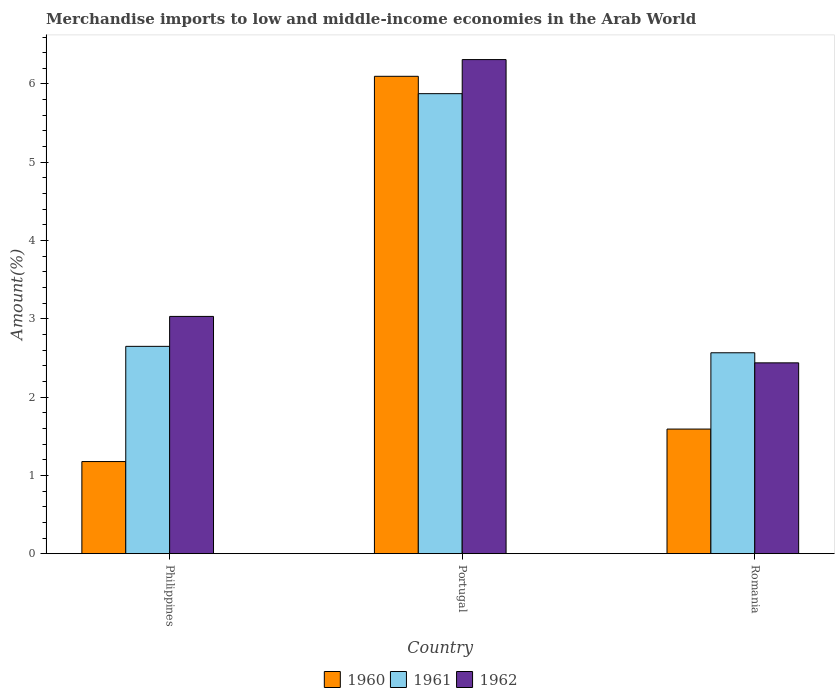How many groups of bars are there?
Your response must be concise. 3. Are the number of bars per tick equal to the number of legend labels?
Your answer should be compact. Yes. How many bars are there on the 2nd tick from the left?
Your response must be concise. 3. How many bars are there on the 3rd tick from the right?
Ensure brevity in your answer.  3. What is the label of the 3rd group of bars from the left?
Provide a short and direct response. Romania. In how many cases, is the number of bars for a given country not equal to the number of legend labels?
Ensure brevity in your answer.  0. What is the percentage of amount earned from merchandise imports in 1962 in Portugal?
Your answer should be compact. 6.31. Across all countries, what is the maximum percentage of amount earned from merchandise imports in 1962?
Make the answer very short. 6.31. Across all countries, what is the minimum percentage of amount earned from merchandise imports in 1961?
Your answer should be compact. 2.57. In which country was the percentage of amount earned from merchandise imports in 1961 minimum?
Give a very brief answer. Romania. What is the total percentage of amount earned from merchandise imports in 1961 in the graph?
Your response must be concise. 11.09. What is the difference between the percentage of amount earned from merchandise imports in 1961 in Portugal and that in Romania?
Your answer should be compact. 3.31. What is the difference between the percentage of amount earned from merchandise imports in 1961 in Portugal and the percentage of amount earned from merchandise imports in 1962 in Philippines?
Keep it short and to the point. 2.85. What is the average percentage of amount earned from merchandise imports in 1962 per country?
Make the answer very short. 3.93. What is the difference between the percentage of amount earned from merchandise imports of/in 1960 and percentage of amount earned from merchandise imports of/in 1962 in Romania?
Offer a very short reply. -0.85. What is the ratio of the percentage of amount earned from merchandise imports in 1960 in Philippines to that in Romania?
Keep it short and to the point. 0.74. Is the percentage of amount earned from merchandise imports in 1962 in Philippines less than that in Portugal?
Provide a short and direct response. Yes. Is the difference between the percentage of amount earned from merchandise imports in 1960 in Philippines and Romania greater than the difference between the percentage of amount earned from merchandise imports in 1962 in Philippines and Romania?
Your answer should be very brief. No. What is the difference between the highest and the second highest percentage of amount earned from merchandise imports in 1960?
Keep it short and to the point. -4.51. What is the difference between the highest and the lowest percentage of amount earned from merchandise imports in 1962?
Provide a succinct answer. 3.87. Are all the bars in the graph horizontal?
Keep it short and to the point. No. What is the difference between two consecutive major ticks on the Y-axis?
Offer a terse response. 1. Where does the legend appear in the graph?
Make the answer very short. Bottom center. How many legend labels are there?
Your response must be concise. 3. How are the legend labels stacked?
Provide a succinct answer. Horizontal. What is the title of the graph?
Provide a short and direct response. Merchandise imports to low and middle-income economies in the Arab World. What is the label or title of the Y-axis?
Ensure brevity in your answer.  Amount(%). What is the Amount(%) in 1960 in Philippines?
Your answer should be very brief. 1.18. What is the Amount(%) in 1961 in Philippines?
Give a very brief answer. 2.65. What is the Amount(%) of 1962 in Philippines?
Ensure brevity in your answer.  3.03. What is the Amount(%) in 1960 in Portugal?
Offer a very short reply. 6.1. What is the Amount(%) in 1961 in Portugal?
Offer a very short reply. 5.88. What is the Amount(%) in 1962 in Portugal?
Make the answer very short. 6.31. What is the Amount(%) of 1960 in Romania?
Offer a terse response. 1.59. What is the Amount(%) of 1961 in Romania?
Make the answer very short. 2.57. What is the Amount(%) in 1962 in Romania?
Your answer should be very brief. 2.44. Across all countries, what is the maximum Amount(%) of 1960?
Make the answer very short. 6.1. Across all countries, what is the maximum Amount(%) of 1961?
Your answer should be compact. 5.88. Across all countries, what is the maximum Amount(%) in 1962?
Your answer should be very brief. 6.31. Across all countries, what is the minimum Amount(%) in 1960?
Offer a very short reply. 1.18. Across all countries, what is the minimum Amount(%) in 1961?
Keep it short and to the point. 2.57. Across all countries, what is the minimum Amount(%) in 1962?
Provide a short and direct response. 2.44. What is the total Amount(%) in 1960 in the graph?
Make the answer very short. 8.87. What is the total Amount(%) of 1961 in the graph?
Your answer should be very brief. 11.09. What is the total Amount(%) in 1962 in the graph?
Provide a short and direct response. 11.78. What is the difference between the Amount(%) of 1960 in Philippines and that in Portugal?
Make the answer very short. -4.92. What is the difference between the Amount(%) of 1961 in Philippines and that in Portugal?
Provide a succinct answer. -3.23. What is the difference between the Amount(%) in 1962 in Philippines and that in Portugal?
Provide a succinct answer. -3.28. What is the difference between the Amount(%) in 1960 in Philippines and that in Romania?
Provide a succinct answer. -0.41. What is the difference between the Amount(%) in 1961 in Philippines and that in Romania?
Make the answer very short. 0.08. What is the difference between the Amount(%) of 1962 in Philippines and that in Romania?
Ensure brevity in your answer.  0.59. What is the difference between the Amount(%) of 1960 in Portugal and that in Romania?
Provide a short and direct response. 4.51. What is the difference between the Amount(%) of 1961 in Portugal and that in Romania?
Ensure brevity in your answer.  3.31. What is the difference between the Amount(%) in 1962 in Portugal and that in Romania?
Ensure brevity in your answer.  3.87. What is the difference between the Amount(%) of 1960 in Philippines and the Amount(%) of 1961 in Portugal?
Offer a terse response. -4.7. What is the difference between the Amount(%) of 1960 in Philippines and the Amount(%) of 1962 in Portugal?
Your answer should be very brief. -5.13. What is the difference between the Amount(%) of 1961 in Philippines and the Amount(%) of 1962 in Portugal?
Keep it short and to the point. -3.66. What is the difference between the Amount(%) in 1960 in Philippines and the Amount(%) in 1961 in Romania?
Keep it short and to the point. -1.39. What is the difference between the Amount(%) in 1960 in Philippines and the Amount(%) in 1962 in Romania?
Give a very brief answer. -1.26. What is the difference between the Amount(%) of 1961 in Philippines and the Amount(%) of 1962 in Romania?
Provide a succinct answer. 0.21. What is the difference between the Amount(%) of 1960 in Portugal and the Amount(%) of 1961 in Romania?
Your answer should be very brief. 3.53. What is the difference between the Amount(%) in 1960 in Portugal and the Amount(%) in 1962 in Romania?
Your answer should be compact. 3.66. What is the difference between the Amount(%) in 1961 in Portugal and the Amount(%) in 1962 in Romania?
Your answer should be compact. 3.44. What is the average Amount(%) of 1960 per country?
Give a very brief answer. 2.96. What is the average Amount(%) in 1961 per country?
Keep it short and to the point. 3.7. What is the average Amount(%) of 1962 per country?
Your answer should be very brief. 3.93. What is the difference between the Amount(%) of 1960 and Amount(%) of 1961 in Philippines?
Offer a terse response. -1.47. What is the difference between the Amount(%) in 1960 and Amount(%) in 1962 in Philippines?
Your response must be concise. -1.85. What is the difference between the Amount(%) in 1961 and Amount(%) in 1962 in Philippines?
Provide a succinct answer. -0.38. What is the difference between the Amount(%) of 1960 and Amount(%) of 1961 in Portugal?
Your answer should be compact. 0.22. What is the difference between the Amount(%) of 1960 and Amount(%) of 1962 in Portugal?
Provide a short and direct response. -0.21. What is the difference between the Amount(%) in 1961 and Amount(%) in 1962 in Portugal?
Your answer should be compact. -0.44. What is the difference between the Amount(%) in 1960 and Amount(%) in 1961 in Romania?
Make the answer very short. -0.97. What is the difference between the Amount(%) of 1960 and Amount(%) of 1962 in Romania?
Provide a succinct answer. -0.85. What is the difference between the Amount(%) in 1961 and Amount(%) in 1962 in Romania?
Your answer should be very brief. 0.13. What is the ratio of the Amount(%) of 1960 in Philippines to that in Portugal?
Make the answer very short. 0.19. What is the ratio of the Amount(%) in 1961 in Philippines to that in Portugal?
Offer a terse response. 0.45. What is the ratio of the Amount(%) of 1962 in Philippines to that in Portugal?
Your answer should be very brief. 0.48. What is the ratio of the Amount(%) of 1960 in Philippines to that in Romania?
Keep it short and to the point. 0.74. What is the ratio of the Amount(%) in 1961 in Philippines to that in Romania?
Ensure brevity in your answer.  1.03. What is the ratio of the Amount(%) of 1962 in Philippines to that in Romania?
Make the answer very short. 1.24. What is the ratio of the Amount(%) in 1960 in Portugal to that in Romania?
Your answer should be very brief. 3.83. What is the ratio of the Amount(%) in 1961 in Portugal to that in Romania?
Provide a short and direct response. 2.29. What is the ratio of the Amount(%) of 1962 in Portugal to that in Romania?
Make the answer very short. 2.59. What is the difference between the highest and the second highest Amount(%) of 1960?
Your answer should be very brief. 4.51. What is the difference between the highest and the second highest Amount(%) of 1961?
Give a very brief answer. 3.23. What is the difference between the highest and the second highest Amount(%) of 1962?
Provide a short and direct response. 3.28. What is the difference between the highest and the lowest Amount(%) of 1960?
Your response must be concise. 4.92. What is the difference between the highest and the lowest Amount(%) of 1961?
Provide a succinct answer. 3.31. What is the difference between the highest and the lowest Amount(%) of 1962?
Give a very brief answer. 3.87. 